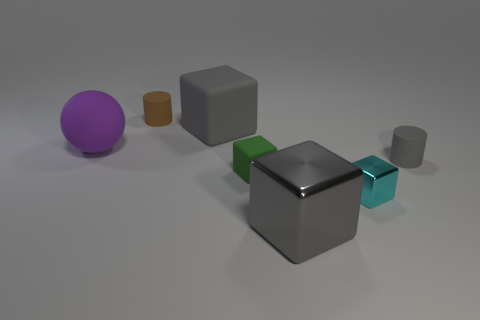Add 1 big purple balls. How many objects exist? 8 Subtract all brown blocks. Subtract all cyan spheres. How many blocks are left? 4 Subtract all balls. How many objects are left? 6 Subtract 1 purple balls. How many objects are left? 6 Subtract all big gray things. Subtract all purple metal spheres. How many objects are left? 5 Add 6 small metallic things. How many small metallic things are left? 7 Add 3 small yellow shiny things. How many small yellow shiny things exist? 3 